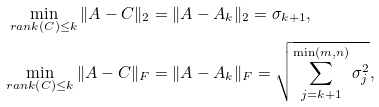Convert formula to latex. <formula><loc_0><loc_0><loc_500><loc_500>\min _ { r a n k \left ( C \right ) \leq k } \| A - C \| _ { 2 } & = \| A - A _ { k } \| _ { 2 } = \sigma _ { k + 1 } , \\ \min _ { r a n k \left ( C \right ) \leq k } \| A - C \| _ { F } & = \| A - A _ { k } \| _ { F } = \sqrt { \sum _ { j = k + 1 } ^ { \min \left ( m , n \right ) } \sigma _ { j } ^ { 2 } } ,</formula> 